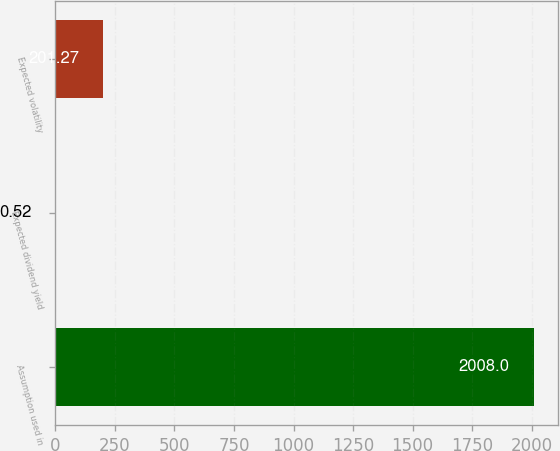Convert chart. <chart><loc_0><loc_0><loc_500><loc_500><bar_chart><fcel>Assumption used in<fcel>Expected dividend yield<fcel>Expected volatility<nl><fcel>2008<fcel>0.52<fcel>201.27<nl></chart> 